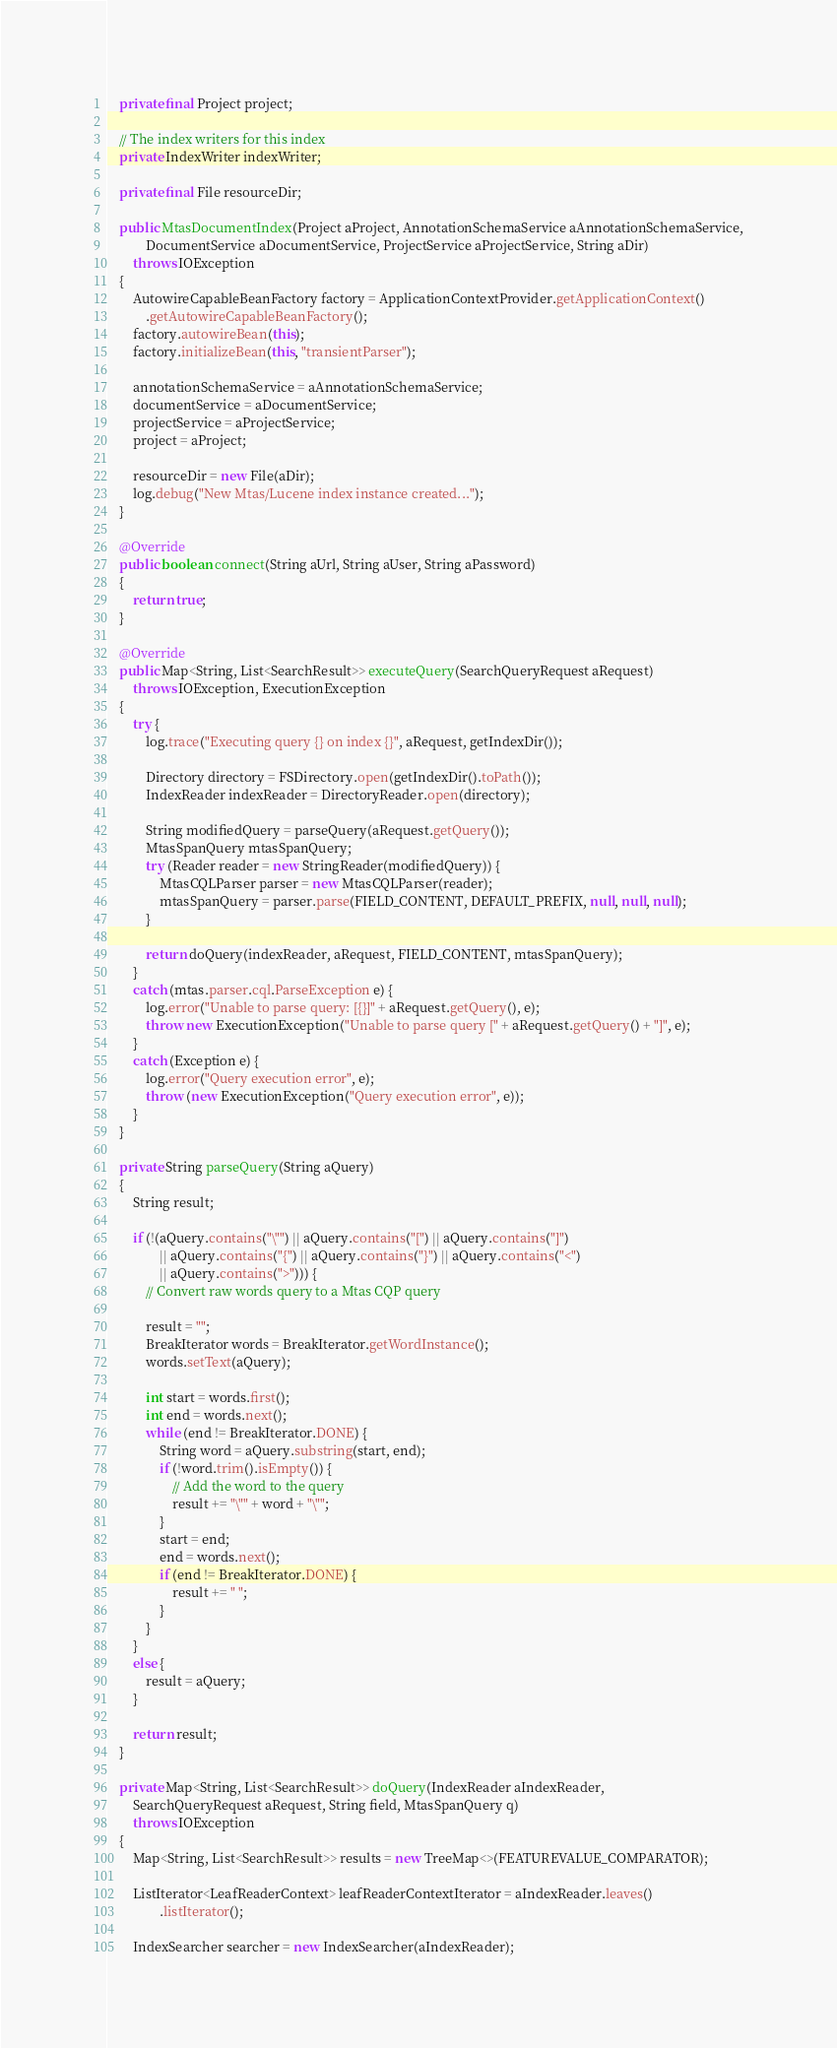Convert code to text. <code><loc_0><loc_0><loc_500><loc_500><_Java_>    private final Project project;

    // The index writers for this index
    private IndexWriter indexWriter;

    private final File resourceDir;

    public MtasDocumentIndex(Project aProject, AnnotationSchemaService aAnnotationSchemaService,
            DocumentService aDocumentService, ProjectService aProjectService, String aDir)
        throws IOException
    {
        AutowireCapableBeanFactory factory = ApplicationContextProvider.getApplicationContext()
            .getAutowireCapableBeanFactory();
        factory.autowireBean(this);
        factory.initializeBean(this, "transientParser");

        annotationSchemaService = aAnnotationSchemaService;
        documentService = aDocumentService;
        projectService = aProjectService;
        project = aProject;
       
        resourceDir = new File(aDir);
        log.debug("New Mtas/Lucene index instance created...");
    }

    @Override
    public boolean connect(String aUrl, String aUser, String aPassword)
    {
        return true;
    }

    @Override
    public Map<String, List<SearchResult>> executeQuery(SearchQueryRequest aRequest)
        throws IOException, ExecutionException
    {
        try {
            log.trace("Executing query {} on index {}", aRequest, getIndexDir());
            
            Directory directory = FSDirectory.open(getIndexDir().toPath());
            IndexReader indexReader = DirectoryReader.open(directory);

            String modifiedQuery = parseQuery(aRequest.getQuery());
            MtasSpanQuery mtasSpanQuery;
            try (Reader reader = new StringReader(modifiedQuery)) {
                MtasCQLParser parser = new MtasCQLParser(reader);
                mtasSpanQuery = parser.parse(FIELD_CONTENT, DEFAULT_PREFIX, null, null, null);
            }
            
            return doQuery(indexReader, aRequest, FIELD_CONTENT, mtasSpanQuery);
        }
        catch (mtas.parser.cql.ParseException e) {
            log.error("Unable to parse query: [{}]" + aRequest.getQuery(), e);
            throw new ExecutionException("Unable to parse query [" + aRequest.getQuery() + "]", e);
        }
        catch (Exception e) {
            log.error("Query execution error", e);
            throw (new ExecutionException("Query execution error", e));
        }
    }

    private String parseQuery(String aQuery)
    {
        String result;

        if (!(aQuery.contains("\"") || aQuery.contains("[") || aQuery.contains("]")
                || aQuery.contains("{") || aQuery.contains("}") || aQuery.contains("<")
                || aQuery.contains(">"))) {
            // Convert raw words query to a Mtas CQP query

            result = "";
            BreakIterator words = BreakIterator.getWordInstance();
            words.setText(aQuery);

            int start = words.first();
            int end = words.next();
            while (end != BreakIterator.DONE) {
                String word = aQuery.substring(start, end);
                if (!word.trim().isEmpty()) {
                    // Add the word to the query
                    result += "\"" + word + "\"";
                }
                start = end;
                end = words.next();
                if (end != BreakIterator.DONE) {
                    result += " ";
                }
            }
        }
        else {
            result = aQuery;
        }

        return result;
    }

    private Map<String, List<SearchResult>> doQuery(IndexReader aIndexReader,
        SearchQueryRequest aRequest, String field, MtasSpanQuery q)
        throws IOException
    {
        Map<String, List<SearchResult>> results = new TreeMap<>(FEATUREVALUE_COMPARATOR);

        ListIterator<LeafReaderContext> leafReaderContextIterator = aIndexReader.leaves()
                .listIterator();

        IndexSearcher searcher = new IndexSearcher(aIndexReader);
</code> 